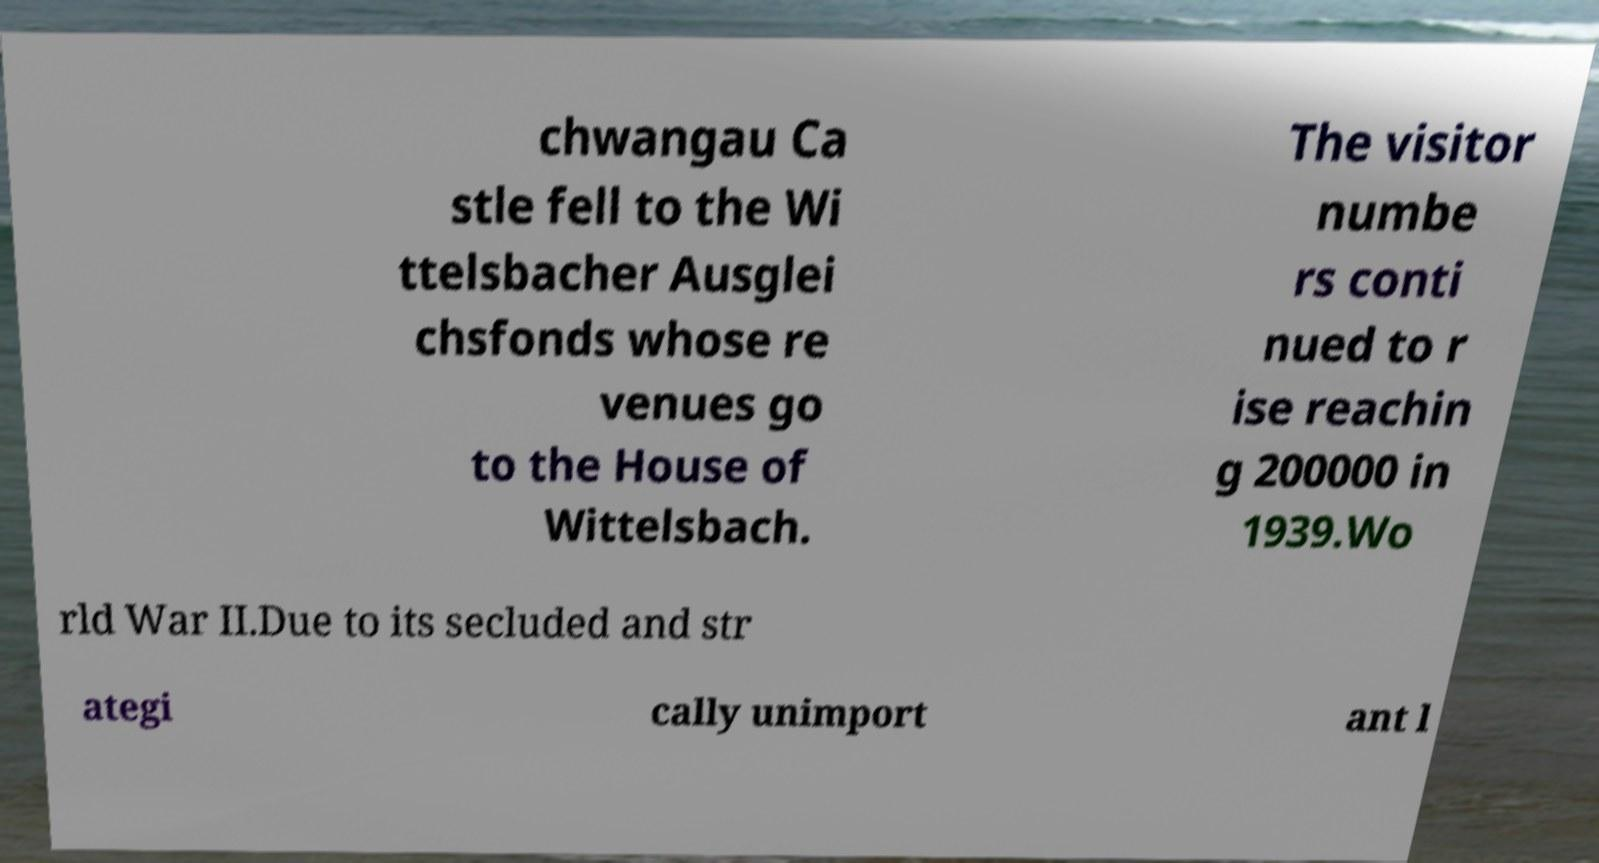Please identify and transcribe the text found in this image. chwangau Ca stle fell to the Wi ttelsbacher Ausglei chsfonds whose re venues go to the House of Wittelsbach. The visitor numbe rs conti nued to r ise reachin g 200000 in 1939.Wo rld War II.Due to its secluded and str ategi cally unimport ant l 